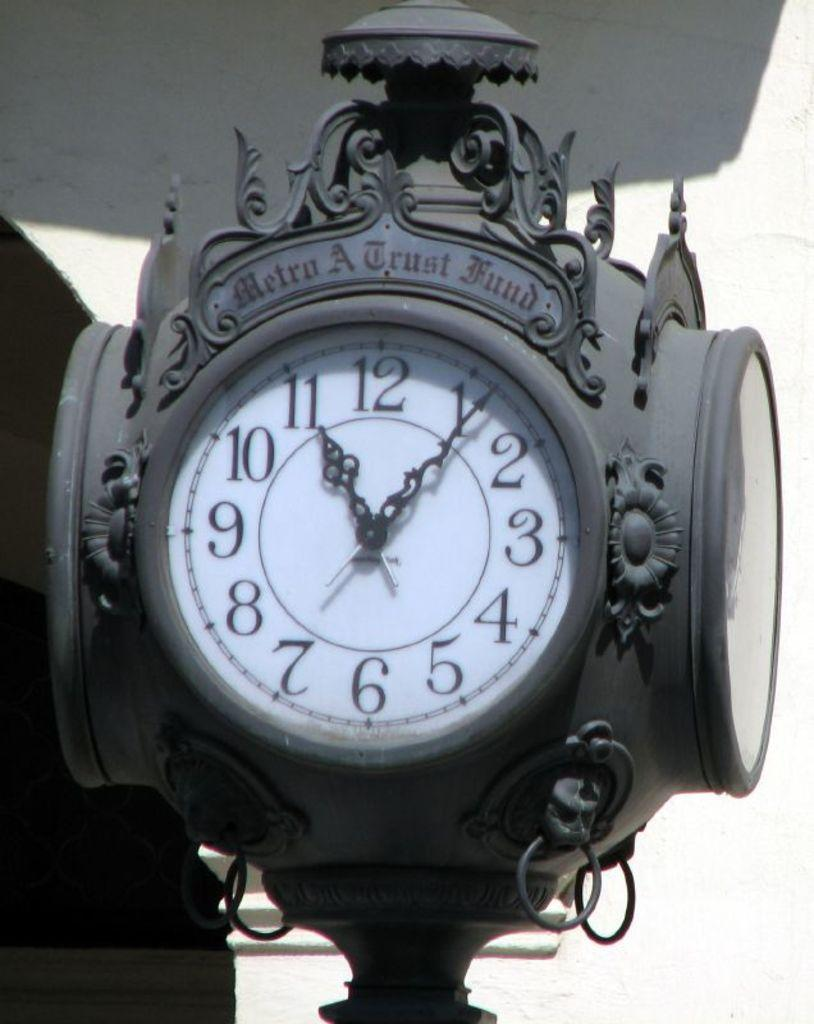<image>
Give a short and clear explanation of the subsequent image. A metro a trust fund clock that is grey in color and outside. 